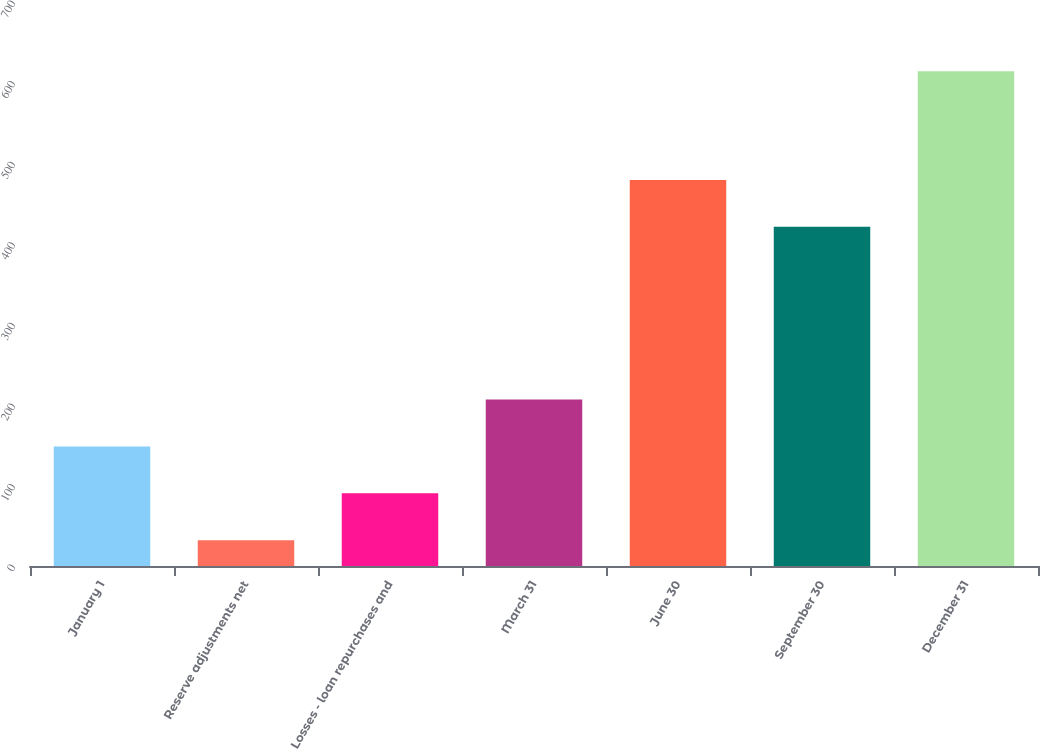Convert chart to OTSL. <chart><loc_0><loc_0><loc_500><loc_500><bar_chart><fcel>January 1<fcel>Reserve adjustments net<fcel>Losses - loan repurchases and<fcel>March 31<fcel>June 30<fcel>September 30<fcel>December 31<nl><fcel>148.4<fcel>32<fcel>90.2<fcel>206.6<fcel>479.2<fcel>421<fcel>614<nl></chart> 